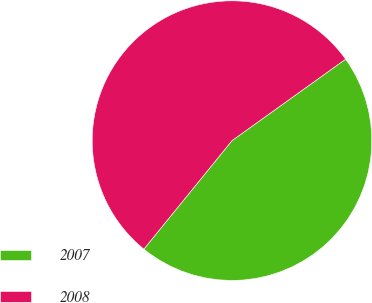Convert chart. <chart><loc_0><loc_0><loc_500><loc_500><pie_chart><fcel>2007<fcel>2008<nl><fcel>45.76%<fcel>54.24%<nl></chart> 